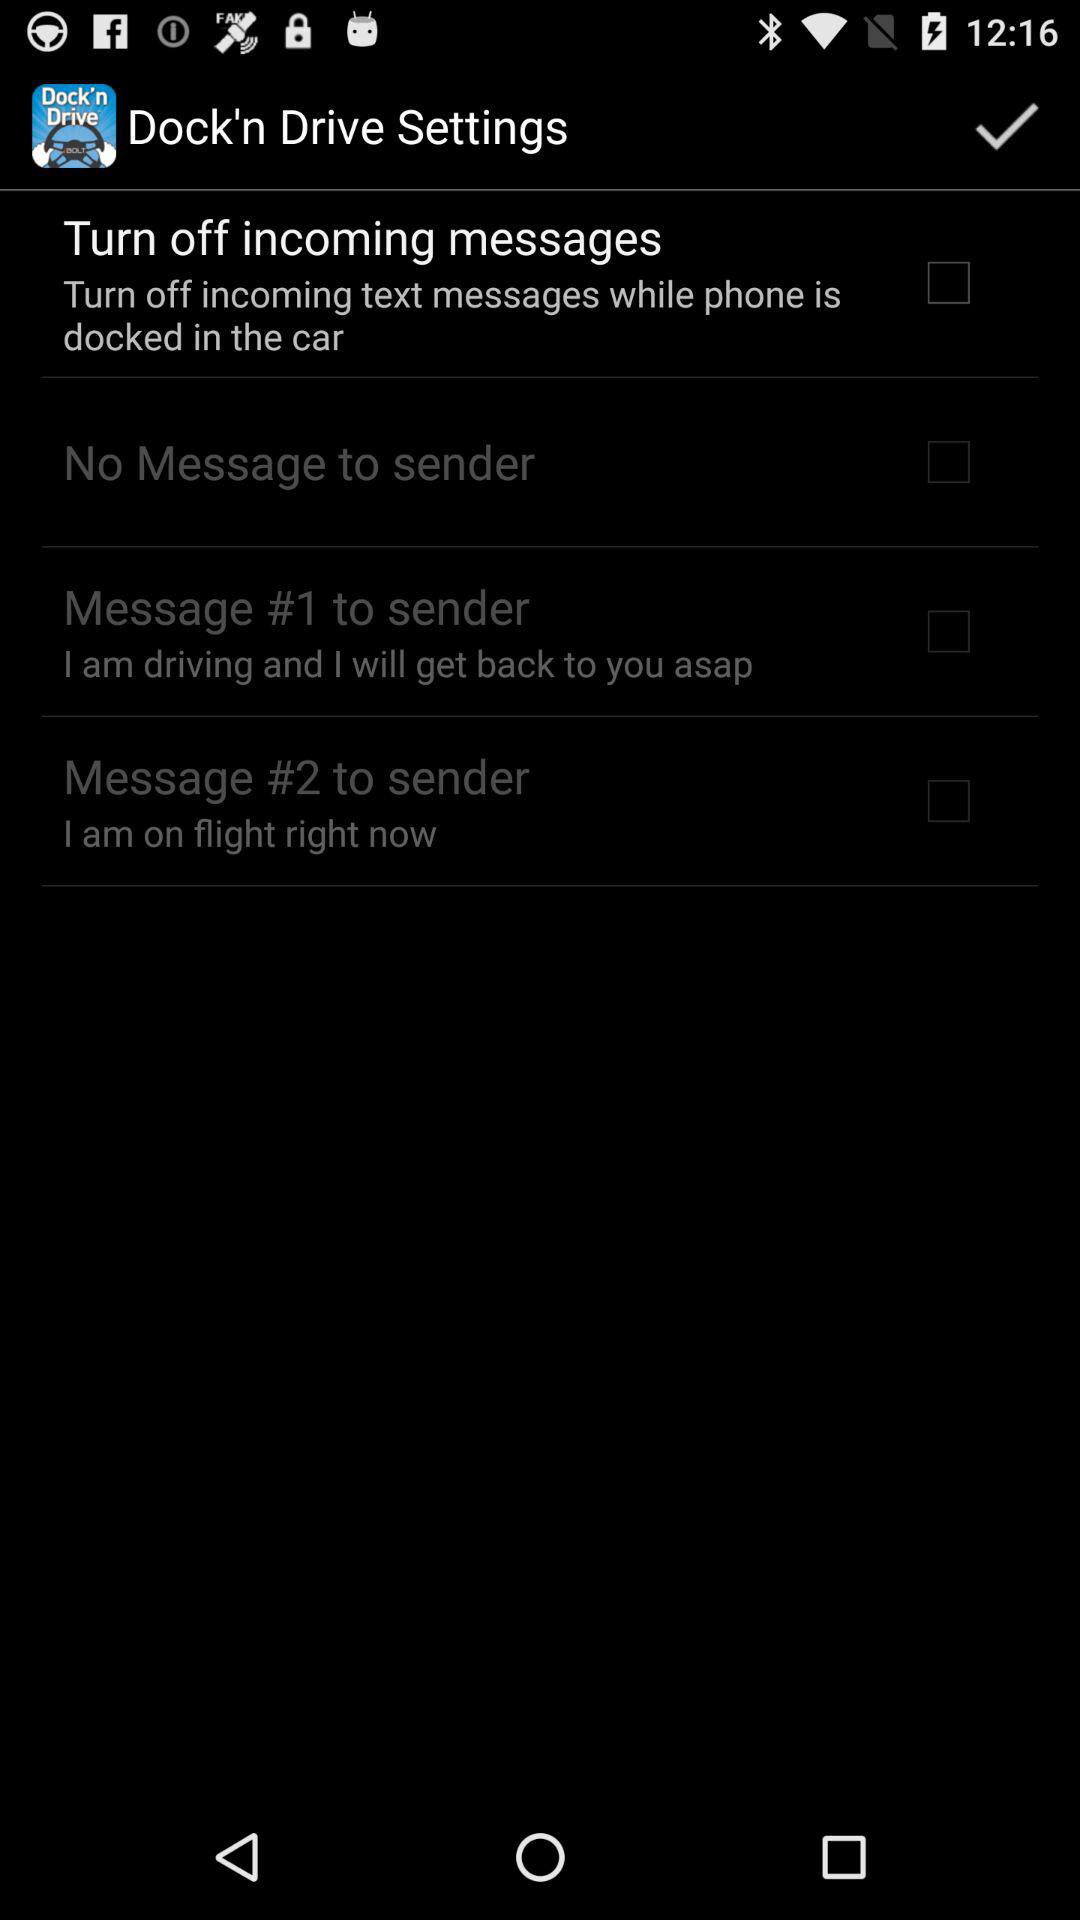What is the setting for "Message #2 to sender"? The setting for "Message #2 to sender" is "I am on flight right now". 